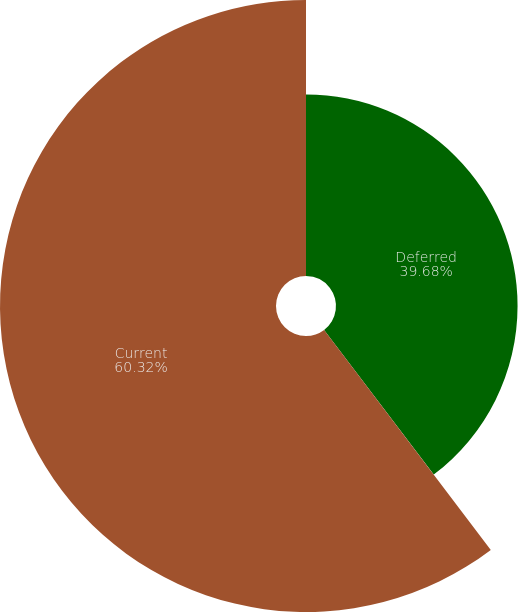Convert chart. <chart><loc_0><loc_0><loc_500><loc_500><pie_chart><fcel>Deferred<fcel>Current<nl><fcel>39.68%<fcel>60.32%<nl></chart> 